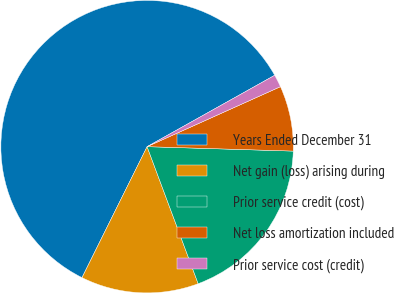Convert chart. <chart><loc_0><loc_0><loc_500><loc_500><pie_chart><fcel>Years Ended December 31<fcel>Net gain (loss) arising during<fcel>Prior service credit (cost)<fcel>Net loss amortization included<fcel>Prior service cost (credit)<nl><fcel>59.54%<fcel>13.02%<fcel>18.84%<fcel>7.21%<fcel>1.39%<nl></chart> 